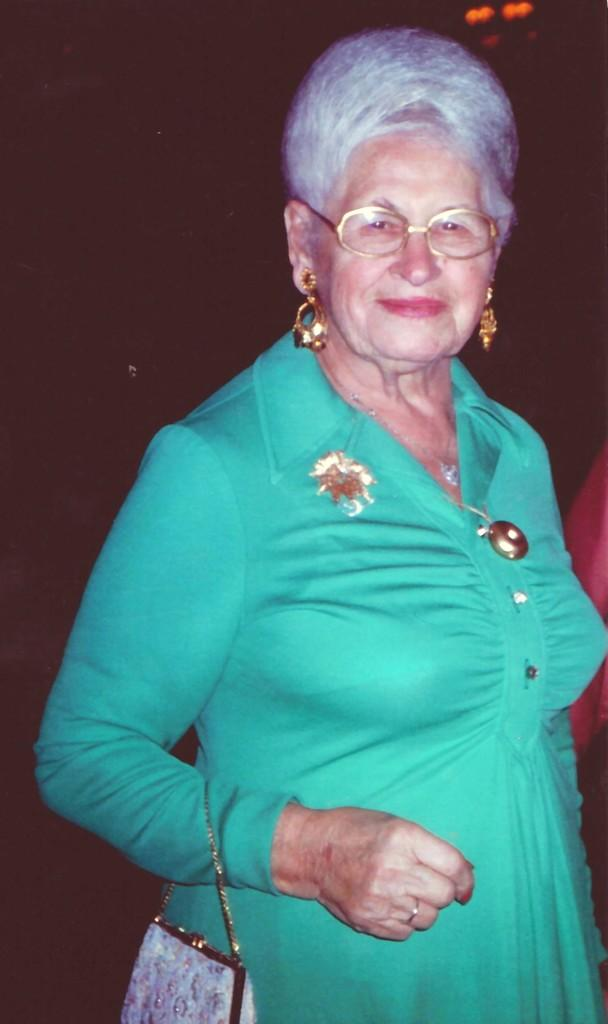What is the main subject of the image? The main subject of the image is a woman. What is the woman doing in the image? The woman is standing in the image. What is the woman wearing in the image? The woman is wearing a green dress, earrings, and spectacles in the image. What is the woman holding in the image? The woman is holding a handbag in the image. What is the color of the handbag? The handbag is light violet in color. What type of oil is being used by the woman in the image? There is no indication in the image that the woman is using any oil. 